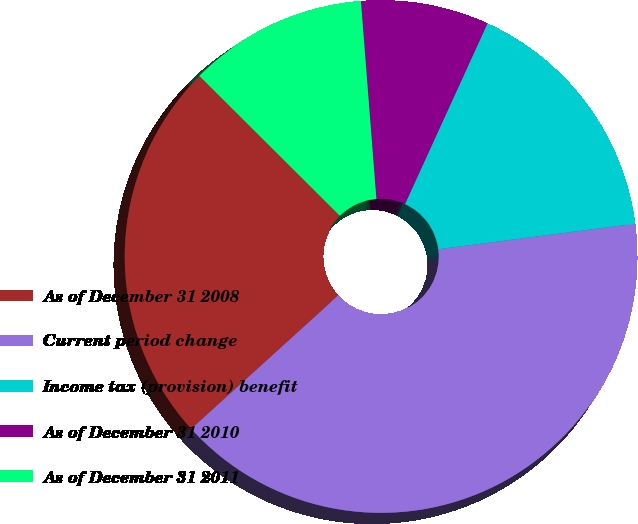Convert chart. <chart><loc_0><loc_0><loc_500><loc_500><pie_chart><fcel>As of December 31 2008<fcel>Current period change<fcel>Income tax (provision) benefit<fcel>As of December 31 2010<fcel>As of December 31 2011<nl><fcel>24.19%<fcel>40.32%<fcel>16.13%<fcel>8.06%<fcel>11.29%<nl></chart> 